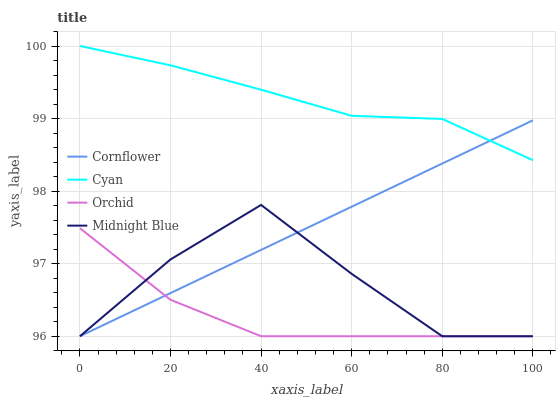Does Orchid have the minimum area under the curve?
Answer yes or no. Yes. Does Cyan have the maximum area under the curve?
Answer yes or no. Yes. Does Midnight Blue have the minimum area under the curve?
Answer yes or no. No. Does Midnight Blue have the maximum area under the curve?
Answer yes or no. No. Is Cornflower the smoothest?
Answer yes or no. Yes. Is Midnight Blue the roughest?
Answer yes or no. Yes. Is Orchid the smoothest?
Answer yes or no. No. Is Orchid the roughest?
Answer yes or no. No. Does Cornflower have the lowest value?
Answer yes or no. Yes. Does Cyan have the lowest value?
Answer yes or no. No. Does Cyan have the highest value?
Answer yes or no. Yes. Does Midnight Blue have the highest value?
Answer yes or no. No. Is Midnight Blue less than Cyan?
Answer yes or no. Yes. Is Cyan greater than Orchid?
Answer yes or no. Yes. Does Cyan intersect Cornflower?
Answer yes or no. Yes. Is Cyan less than Cornflower?
Answer yes or no. No. Is Cyan greater than Cornflower?
Answer yes or no. No. Does Midnight Blue intersect Cyan?
Answer yes or no. No. 